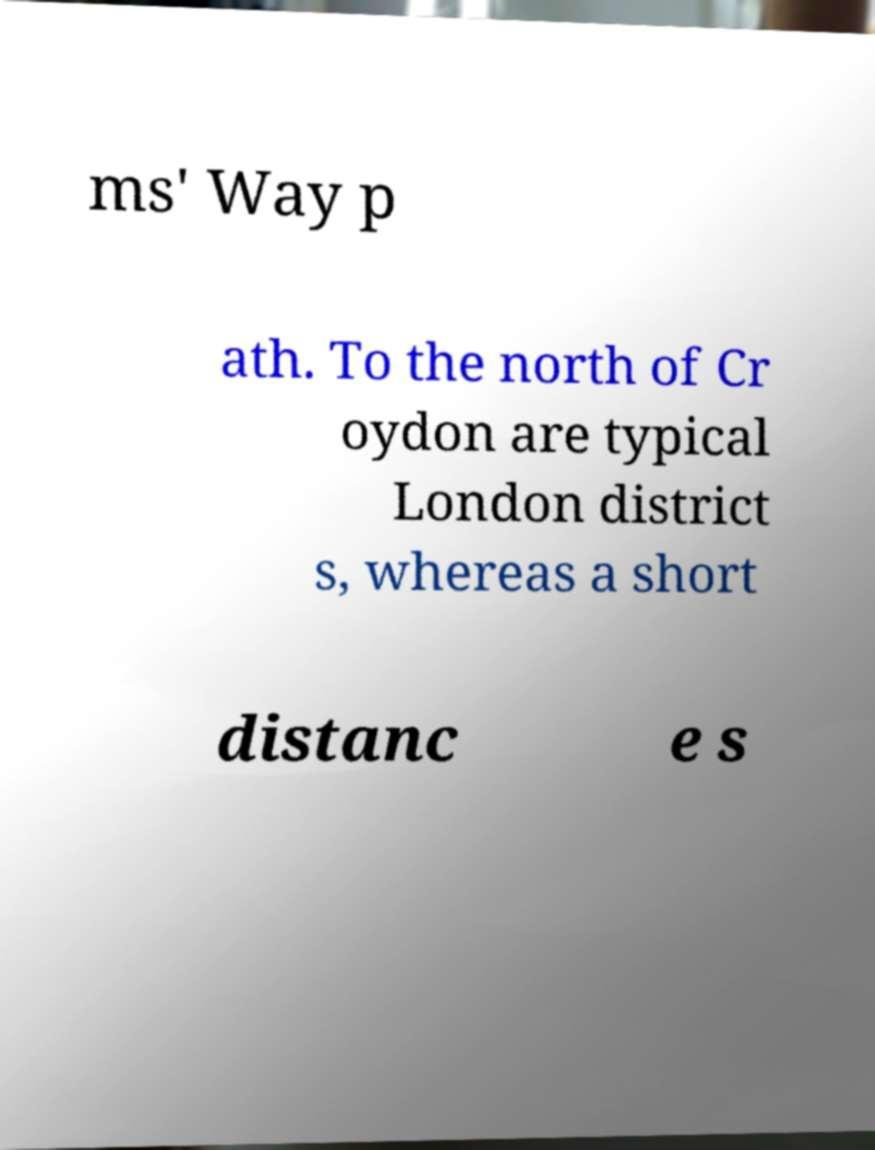What messages or text are displayed in this image? I need them in a readable, typed format. ms' Way p ath. To the north of Cr oydon are typical London district s, whereas a short distanc e s 